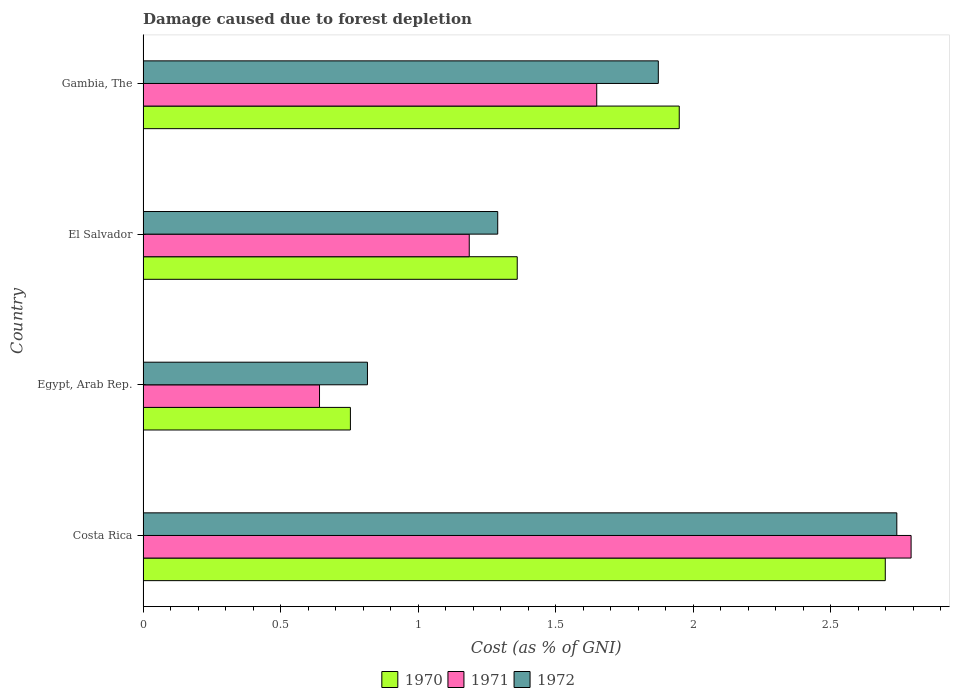How many bars are there on the 2nd tick from the top?
Provide a short and direct response. 3. What is the label of the 2nd group of bars from the top?
Give a very brief answer. El Salvador. In how many cases, is the number of bars for a given country not equal to the number of legend labels?
Make the answer very short. 0. What is the cost of damage caused due to forest depletion in 1972 in Gambia, The?
Offer a very short reply. 1.87. Across all countries, what is the maximum cost of damage caused due to forest depletion in 1971?
Your answer should be very brief. 2.79. Across all countries, what is the minimum cost of damage caused due to forest depletion in 1970?
Keep it short and to the point. 0.75. In which country was the cost of damage caused due to forest depletion in 1970 minimum?
Your answer should be compact. Egypt, Arab Rep. What is the total cost of damage caused due to forest depletion in 1970 in the graph?
Your response must be concise. 6.76. What is the difference between the cost of damage caused due to forest depletion in 1971 in Costa Rica and that in Egypt, Arab Rep.?
Your answer should be compact. 2.15. What is the difference between the cost of damage caused due to forest depletion in 1971 in Gambia, The and the cost of damage caused due to forest depletion in 1972 in El Salvador?
Make the answer very short. 0.36. What is the average cost of damage caused due to forest depletion in 1972 per country?
Give a very brief answer. 1.68. What is the difference between the cost of damage caused due to forest depletion in 1971 and cost of damage caused due to forest depletion in 1972 in Gambia, The?
Your answer should be compact. -0.22. In how many countries, is the cost of damage caused due to forest depletion in 1970 greater than 2.6 %?
Your answer should be compact. 1. What is the ratio of the cost of damage caused due to forest depletion in 1972 in Costa Rica to that in Gambia, The?
Your answer should be very brief. 1.46. Is the cost of damage caused due to forest depletion in 1971 in Costa Rica less than that in Gambia, The?
Offer a terse response. No. What is the difference between the highest and the second highest cost of damage caused due to forest depletion in 1972?
Make the answer very short. 0.87. What is the difference between the highest and the lowest cost of damage caused due to forest depletion in 1971?
Your answer should be compact. 2.15. Is it the case that in every country, the sum of the cost of damage caused due to forest depletion in 1972 and cost of damage caused due to forest depletion in 1970 is greater than the cost of damage caused due to forest depletion in 1971?
Provide a succinct answer. Yes. How many bars are there?
Provide a succinct answer. 12. Are all the bars in the graph horizontal?
Offer a terse response. Yes. How many legend labels are there?
Your response must be concise. 3. How are the legend labels stacked?
Your response must be concise. Horizontal. What is the title of the graph?
Ensure brevity in your answer.  Damage caused due to forest depletion. What is the label or title of the X-axis?
Keep it short and to the point. Cost (as % of GNI). What is the Cost (as % of GNI) of 1970 in Costa Rica?
Make the answer very short. 2.7. What is the Cost (as % of GNI) of 1971 in Costa Rica?
Keep it short and to the point. 2.79. What is the Cost (as % of GNI) in 1972 in Costa Rica?
Give a very brief answer. 2.74. What is the Cost (as % of GNI) of 1970 in Egypt, Arab Rep.?
Ensure brevity in your answer.  0.75. What is the Cost (as % of GNI) of 1971 in Egypt, Arab Rep.?
Ensure brevity in your answer.  0.64. What is the Cost (as % of GNI) in 1972 in Egypt, Arab Rep.?
Provide a short and direct response. 0.82. What is the Cost (as % of GNI) in 1970 in El Salvador?
Provide a short and direct response. 1.36. What is the Cost (as % of GNI) of 1971 in El Salvador?
Your response must be concise. 1.19. What is the Cost (as % of GNI) of 1972 in El Salvador?
Provide a short and direct response. 1.29. What is the Cost (as % of GNI) in 1970 in Gambia, The?
Offer a terse response. 1.95. What is the Cost (as % of GNI) of 1971 in Gambia, The?
Offer a very short reply. 1.65. What is the Cost (as % of GNI) in 1972 in Gambia, The?
Ensure brevity in your answer.  1.87. Across all countries, what is the maximum Cost (as % of GNI) in 1970?
Give a very brief answer. 2.7. Across all countries, what is the maximum Cost (as % of GNI) of 1971?
Provide a succinct answer. 2.79. Across all countries, what is the maximum Cost (as % of GNI) in 1972?
Provide a succinct answer. 2.74. Across all countries, what is the minimum Cost (as % of GNI) in 1970?
Provide a succinct answer. 0.75. Across all countries, what is the minimum Cost (as % of GNI) in 1971?
Keep it short and to the point. 0.64. Across all countries, what is the minimum Cost (as % of GNI) of 1972?
Give a very brief answer. 0.82. What is the total Cost (as % of GNI) of 1970 in the graph?
Your answer should be compact. 6.76. What is the total Cost (as % of GNI) of 1971 in the graph?
Your response must be concise. 6.27. What is the total Cost (as % of GNI) of 1972 in the graph?
Give a very brief answer. 6.72. What is the difference between the Cost (as % of GNI) in 1970 in Costa Rica and that in Egypt, Arab Rep.?
Offer a terse response. 1.94. What is the difference between the Cost (as % of GNI) in 1971 in Costa Rica and that in Egypt, Arab Rep.?
Your answer should be compact. 2.15. What is the difference between the Cost (as % of GNI) of 1972 in Costa Rica and that in Egypt, Arab Rep.?
Provide a short and direct response. 1.92. What is the difference between the Cost (as % of GNI) of 1970 in Costa Rica and that in El Salvador?
Make the answer very short. 1.34. What is the difference between the Cost (as % of GNI) of 1971 in Costa Rica and that in El Salvador?
Make the answer very short. 1.61. What is the difference between the Cost (as % of GNI) in 1972 in Costa Rica and that in El Salvador?
Your answer should be very brief. 1.45. What is the difference between the Cost (as % of GNI) in 1970 in Costa Rica and that in Gambia, The?
Your answer should be compact. 0.75. What is the difference between the Cost (as % of GNI) of 1972 in Costa Rica and that in Gambia, The?
Your answer should be compact. 0.87. What is the difference between the Cost (as % of GNI) of 1970 in Egypt, Arab Rep. and that in El Salvador?
Give a very brief answer. -0.61. What is the difference between the Cost (as % of GNI) in 1971 in Egypt, Arab Rep. and that in El Salvador?
Your response must be concise. -0.54. What is the difference between the Cost (as % of GNI) in 1972 in Egypt, Arab Rep. and that in El Salvador?
Offer a terse response. -0.47. What is the difference between the Cost (as % of GNI) of 1970 in Egypt, Arab Rep. and that in Gambia, The?
Your response must be concise. -1.2. What is the difference between the Cost (as % of GNI) in 1971 in Egypt, Arab Rep. and that in Gambia, The?
Provide a short and direct response. -1.01. What is the difference between the Cost (as % of GNI) in 1972 in Egypt, Arab Rep. and that in Gambia, The?
Your answer should be very brief. -1.06. What is the difference between the Cost (as % of GNI) of 1970 in El Salvador and that in Gambia, The?
Offer a terse response. -0.59. What is the difference between the Cost (as % of GNI) in 1971 in El Salvador and that in Gambia, The?
Provide a short and direct response. -0.46. What is the difference between the Cost (as % of GNI) in 1972 in El Salvador and that in Gambia, The?
Keep it short and to the point. -0.58. What is the difference between the Cost (as % of GNI) of 1970 in Costa Rica and the Cost (as % of GNI) of 1971 in Egypt, Arab Rep.?
Keep it short and to the point. 2.06. What is the difference between the Cost (as % of GNI) of 1970 in Costa Rica and the Cost (as % of GNI) of 1972 in Egypt, Arab Rep.?
Provide a short and direct response. 1.88. What is the difference between the Cost (as % of GNI) in 1971 in Costa Rica and the Cost (as % of GNI) in 1972 in Egypt, Arab Rep.?
Your response must be concise. 1.98. What is the difference between the Cost (as % of GNI) of 1970 in Costa Rica and the Cost (as % of GNI) of 1971 in El Salvador?
Your answer should be very brief. 1.51. What is the difference between the Cost (as % of GNI) in 1970 in Costa Rica and the Cost (as % of GNI) in 1972 in El Salvador?
Your response must be concise. 1.41. What is the difference between the Cost (as % of GNI) of 1971 in Costa Rica and the Cost (as % of GNI) of 1972 in El Salvador?
Ensure brevity in your answer.  1.5. What is the difference between the Cost (as % of GNI) of 1970 in Costa Rica and the Cost (as % of GNI) of 1971 in Gambia, The?
Your answer should be very brief. 1.05. What is the difference between the Cost (as % of GNI) in 1970 in Costa Rica and the Cost (as % of GNI) in 1972 in Gambia, The?
Offer a terse response. 0.83. What is the difference between the Cost (as % of GNI) in 1971 in Costa Rica and the Cost (as % of GNI) in 1972 in Gambia, The?
Give a very brief answer. 0.92. What is the difference between the Cost (as % of GNI) in 1970 in Egypt, Arab Rep. and the Cost (as % of GNI) in 1971 in El Salvador?
Provide a short and direct response. -0.43. What is the difference between the Cost (as % of GNI) in 1970 in Egypt, Arab Rep. and the Cost (as % of GNI) in 1972 in El Salvador?
Offer a terse response. -0.54. What is the difference between the Cost (as % of GNI) in 1971 in Egypt, Arab Rep. and the Cost (as % of GNI) in 1972 in El Salvador?
Provide a short and direct response. -0.65. What is the difference between the Cost (as % of GNI) in 1970 in Egypt, Arab Rep. and the Cost (as % of GNI) in 1971 in Gambia, The?
Your response must be concise. -0.9. What is the difference between the Cost (as % of GNI) of 1970 in Egypt, Arab Rep. and the Cost (as % of GNI) of 1972 in Gambia, The?
Offer a very short reply. -1.12. What is the difference between the Cost (as % of GNI) of 1971 in Egypt, Arab Rep. and the Cost (as % of GNI) of 1972 in Gambia, The?
Offer a very short reply. -1.23. What is the difference between the Cost (as % of GNI) of 1970 in El Salvador and the Cost (as % of GNI) of 1971 in Gambia, The?
Keep it short and to the point. -0.29. What is the difference between the Cost (as % of GNI) in 1970 in El Salvador and the Cost (as % of GNI) in 1972 in Gambia, The?
Offer a very short reply. -0.51. What is the difference between the Cost (as % of GNI) in 1971 in El Salvador and the Cost (as % of GNI) in 1972 in Gambia, The?
Provide a succinct answer. -0.69. What is the average Cost (as % of GNI) of 1970 per country?
Your response must be concise. 1.69. What is the average Cost (as % of GNI) of 1971 per country?
Ensure brevity in your answer.  1.57. What is the average Cost (as % of GNI) of 1972 per country?
Your response must be concise. 1.68. What is the difference between the Cost (as % of GNI) in 1970 and Cost (as % of GNI) in 1971 in Costa Rica?
Offer a very short reply. -0.09. What is the difference between the Cost (as % of GNI) in 1970 and Cost (as % of GNI) in 1972 in Costa Rica?
Keep it short and to the point. -0.04. What is the difference between the Cost (as % of GNI) in 1971 and Cost (as % of GNI) in 1972 in Costa Rica?
Give a very brief answer. 0.05. What is the difference between the Cost (as % of GNI) of 1970 and Cost (as % of GNI) of 1971 in Egypt, Arab Rep.?
Keep it short and to the point. 0.11. What is the difference between the Cost (as % of GNI) in 1970 and Cost (as % of GNI) in 1972 in Egypt, Arab Rep.?
Provide a succinct answer. -0.06. What is the difference between the Cost (as % of GNI) in 1971 and Cost (as % of GNI) in 1972 in Egypt, Arab Rep.?
Your answer should be compact. -0.17. What is the difference between the Cost (as % of GNI) in 1970 and Cost (as % of GNI) in 1971 in El Salvador?
Your answer should be very brief. 0.17. What is the difference between the Cost (as % of GNI) of 1970 and Cost (as % of GNI) of 1972 in El Salvador?
Give a very brief answer. 0.07. What is the difference between the Cost (as % of GNI) of 1971 and Cost (as % of GNI) of 1972 in El Salvador?
Offer a terse response. -0.1. What is the difference between the Cost (as % of GNI) in 1970 and Cost (as % of GNI) in 1971 in Gambia, The?
Offer a very short reply. 0.3. What is the difference between the Cost (as % of GNI) of 1970 and Cost (as % of GNI) of 1972 in Gambia, The?
Make the answer very short. 0.08. What is the difference between the Cost (as % of GNI) in 1971 and Cost (as % of GNI) in 1972 in Gambia, The?
Give a very brief answer. -0.22. What is the ratio of the Cost (as % of GNI) of 1970 in Costa Rica to that in Egypt, Arab Rep.?
Provide a succinct answer. 3.58. What is the ratio of the Cost (as % of GNI) of 1971 in Costa Rica to that in Egypt, Arab Rep.?
Provide a succinct answer. 4.35. What is the ratio of the Cost (as % of GNI) of 1972 in Costa Rica to that in Egypt, Arab Rep.?
Your response must be concise. 3.36. What is the ratio of the Cost (as % of GNI) of 1970 in Costa Rica to that in El Salvador?
Your answer should be compact. 1.98. What is the ratio of the Cost (as % of GNI) in 1971 in Costa Rica to that in El Salvador?
Make the answer very short. 2.35. What is the ratio of the Cost (as % of GNI) of 1972 in Costa Rica to that in El Salvador?
Your answer should be compact. 2.13. What is the ratio of the Cost (as % of GNI) of 1970 in Costa Rica to that in Gambia, The?
Offer a very short reply. 1.38. What is the ratio of the Cost (as % of GNI) of 1971 in Costa Rica to that in Gambia, The?
Offer a very short reply. 1.69. What is the ratio of the Cost (as % of GNI) in 1972 in Costa Rica to that in Gambia, The?
Make the answer very short. 1.46. What is the ratio of the Cost (as % of GNI) in 1970 in Egypt, Arab Rep. to that in El Salvador?
Your response must be concise. 0.55. What is the ratio of the Cost (as % of GNI) in 1971 in Egypt, Arab Rep. to that in El Salvador?
Offer a very short reply. 0.54. What is the ratio of the Cost (as % of GNI) in 1972 in Egypt, Arab Rep. to that in El Salvador?
Keep it short and to the point. 0.63. What is the ratio of the Cost (as % of GNI) of 1970 in Egypt, Arab Rep. to that in Gambia, The?
Give a very brief answer. 0.39. What is the ratio of the Cost (as % of GNI) in 1971 in Egypt, Arab Rep. to that in Gambia, The?
Provide a short and direct response. 0.39. What is the ratio of the Cost (as % of GNI) of 1972 in Egypt, Arab Rep. to that in Gambia, The?
Offer a very short reply. 0.44. What is the ratio of the Cost (as % of GNI) in 1970 in El Salvador to that in Gambia, The?
Provide a succinct answer. 0.7. What is the ratio of the Cost (as % of GNI) in 1971 in El Salvador to that in Gambia, The?
Offer a terse response. 0.72. What is the ratio of the Cost (as % of GNI) in 1972 in El Salvador to that in Gambia, The?
Give a very brief answer. 0.69. What is the difference between the highest and the second highest Cost (as % of GNI) of 1970?
Offer a very short reply. 0.75. What is the difference between the highest and the second highest Cost (as % of GNI) of 1972?
Your answer should be compact. 0.87. What is the difference between the highest and the lowest Cost (as % of GNI) in 1970?
Give a very brief answer. 1.94. What is the difference between the highest and the lowest Cost (as % of GNI) of 1971?
Your response must be concise. 2.15. What is the difference between the highest and the lowest Cost (as % of GNI) of 1972?
Provide a succinct answer. 1.92. 